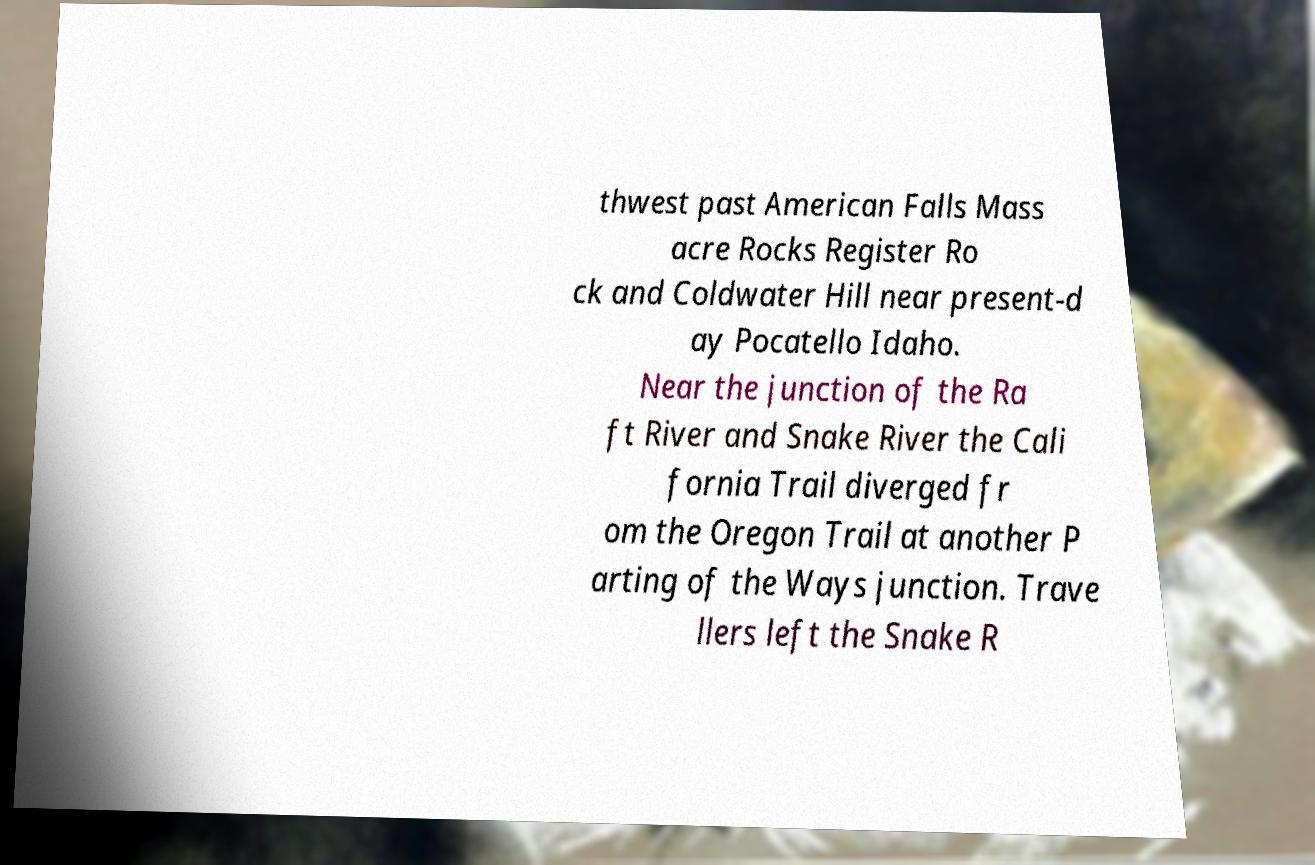Can you accurately transcribe the text from the provided image for me? thwest past American Falls Mass acre Rocks Register Ro ck and Coldwater Hill near present-d ay Pocatello Idaho. Near the junction of the Ra ft River and Snake River the Cali fornia Trail diverged fr om the Oregon Trail at another P arting of the Ways junction. Trave llers left the Snake R 